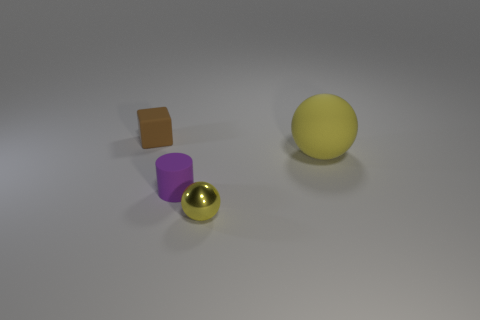Are there any other things that have the same material as the tiny yellow sphere?
Provide a succinct answer. No. What number of objects are behind the tiny yellow thing and in front of the small brown rubber block?
Offer a terse response. 2. There is a tiny metal thing; how many yellow balls are behind it?
Offer a very short reply. 1. Is there another thing of the same shape as the big yellow thing?
Provide a short and direct response. Yes. There is a tiny brown thing; does it have the same shape as the object right of the metallic sphere?
Your answer should be compact. No. How many cubes are small brown rubber things or yellow things?
Your answer should be compact. 1. The yellow object behind the yellow metallic object has what shape?
Give a very brief answer. Sphere. What number of tiny spheres are the same material as the tiny block?
Offer a terse response. 0. Is the number of tiny yellow balls that are behind the tiny cylinder less than the number of shiny blocks?
Your answer should be very brief. No. There is a thing that is to the left of the small matte object that is right of the brown thing; what is its size?
Make the answer very short. Small. 